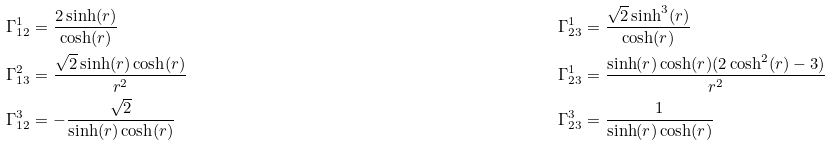Convert formula to latex. <formula><loc_0><loc_0><loc_500><loc_500>& \Gamma _ { 1 2 } ^ { 1 } = \frac { 2 \sinh ( r ) } { \cosh ( r ) } & & \Gamma _ { 2 3 } ^ { 1 } = \frac { \sqrt { 2 } \sinh ^ { 3 } ( r ) } { \cosh ( r ) } \\ & \Gamma _ { 1 3 } ^ { 2 } = \frac { \sqrt { 2 } \sinh ( r ) \cosh ( r ) } { r ^ { 2 } } & & \Gamma _ { 2 3 } ^ { 1 } = \frac { \sinh ( r ) \cosh ( r ) ( 2 \cosh ^ { 2 } ( r ) - 3 ) } { r ^ { 2 } } \\ & \Gamma _ { 1 2 } ^ { 3 } = - \frac { \sqrt { 2 } } { \sinh ( r ) \cosh ( r ) } & & \Gamma _ { 2 3 } ^ { 3 } = \frac { 1 } { \sinh ( r ) \cosh ( r ) }</formula> 